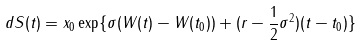<formula> <loc_0><loc_0><loc_500><loc_500>d S ( t ) = x _ { 0 } \exp \{ \sigma ( W ( t ) - W ( t _ { 0 } ) ) + ( r - \frac { 1 } { 2 } \sigma ^ { 2 } ) ( t - t _ { 0 } ) \}</formula> 